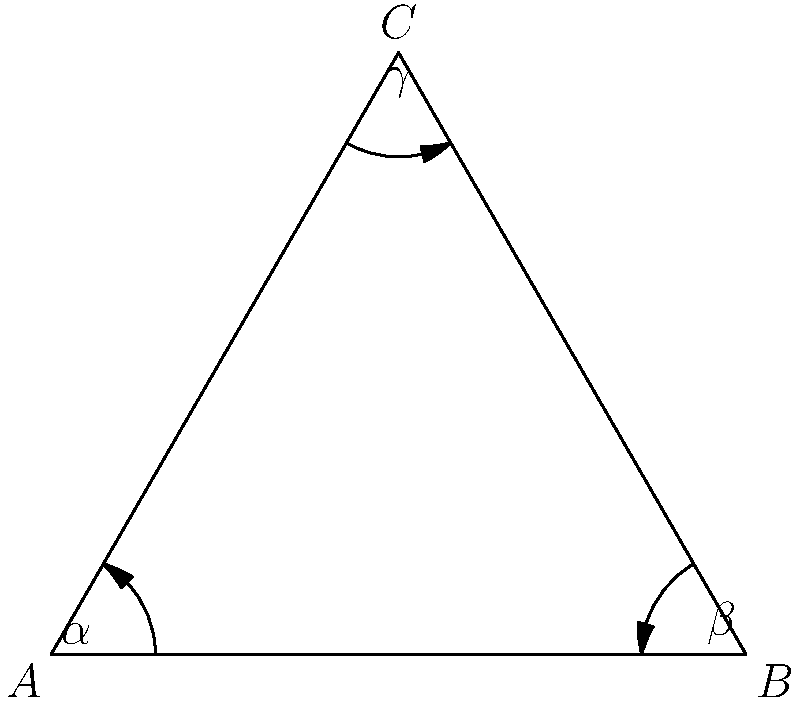In a hyperbolic plane, a triangle ABC has angles $\alpha = 30°$, $\beta = 45°$, and $\gamma = 60°$. Calculate the area of this hyperbolic triangle using the formula $Area = \pi - (\alpha + \beta + \gamma)$, where angles are in radians. How does this result compare to the area of a Euclidean triangle with the same angles, and what implications might this have for textile patterns in non-Euclidean geometries? To solve this problem, we'll follow these steps:

1) Convert the given angles from degrees to radians:
   $\alpha = 30° = \frac{\pi}{6}$ radians
   $\beta = 45° = \frac{\pi}{4}$ radians
   $\gamma = 60° = \frac{\pi}{3}$ radians

2) Apply the formula for the area of a hyperbolic triangle:
   $Area = \pi - (\alpha + \beta + \gamma)$

3) Substitute the values:
   $Area = \pi - (\frac{\pi}{6} + \frac{\pi}{4} + \frac{\pi}{3})$

4) Simplify:
   $Area = \pi - (\frac{2\pi}{12} + \frac{3\pi}{12} + \frac{4\pi}{12})$
   $Area = \pi - \frac{9\pi}{12}$
   $Area = \frac{3\pi}{12} = \frac{\pi}{4}$

5) Compare to Euclidean geometry:
   In Euclidean geometry, the sum of angles in a triangle is always $\pi$ radians or 180°, and the area formula doesn't depend on the angles.
   
   In this hyperbolic triangle, the sum of angles is $\frac{\pi}{6} + \frac{\pi}{4} + \frac{\pi}{3} = \frac{9\pi}{12} = \frac{3\pi}{4} = 135°$, which is less than 180°.

6) Implications for textile patterns:
   This result implies that in hyperbolic geometry, triangles with the same angles can have different areas, unlike in Euclidean geometry. For textile patterns, this could lead to interesting designs where triangular shapes might appear distorted or have unexpected properties when mapped onto non-Euclidean surfaces.
Answer: $\frac{\pi}{4}$ square units 